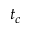<formula> <loc_0><loc_0><loc_500><loc_500>t _ { c }</formula> 